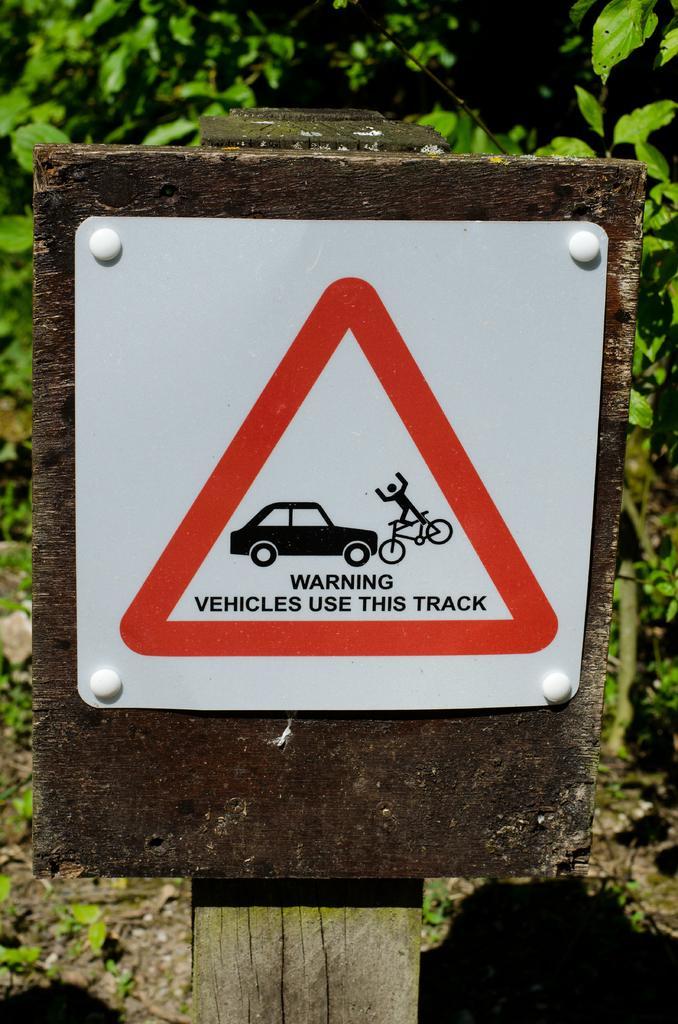How would you summarize this image in a sentence or two? In this image I can see a sign board attached to the wooden board. It is in white,red and black color. Back I can see trees. 